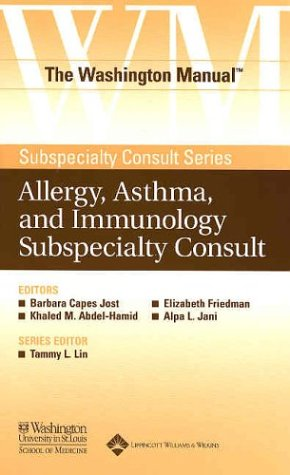What type of book is this? This is a medical reference book within the genre of Health, Fitness, and Dieting, specifically tailored towards professionals seeking guidance on allergy, asthma, and immunology. 